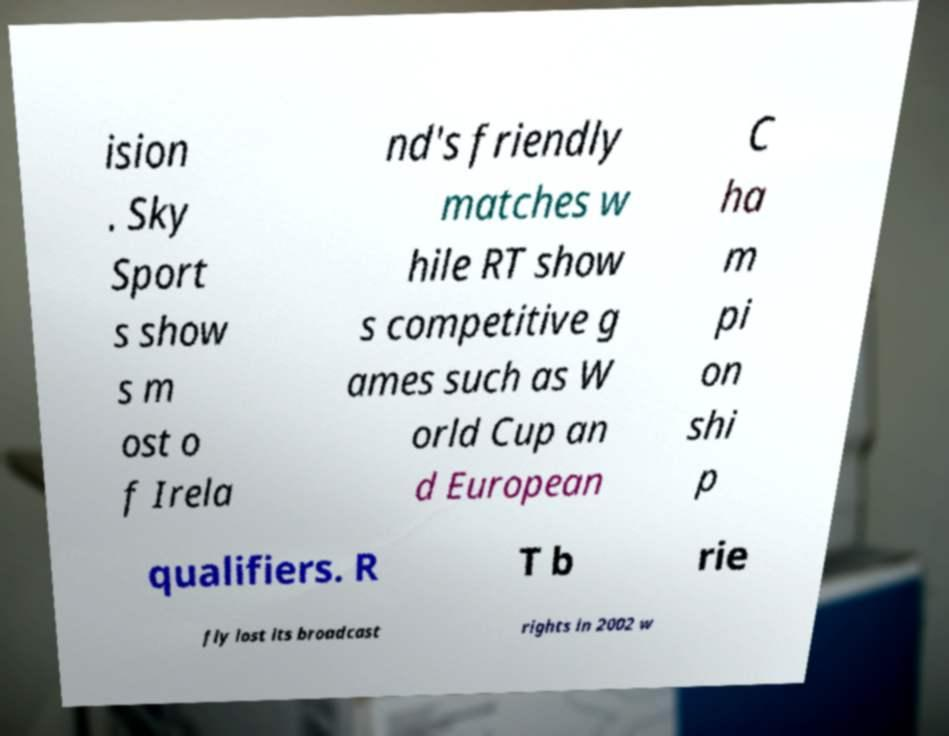Could you assist in decoding the text presented in this image and type it out clearly? ision . Sky Sport s show s m ost o f Irela nd's friendly matches w hile RT show s competitive g ames such as W orld Cup an d European C ha m pi on shi p qualifiers. R T b rie fly lost its broadcast rights in 2002 w 